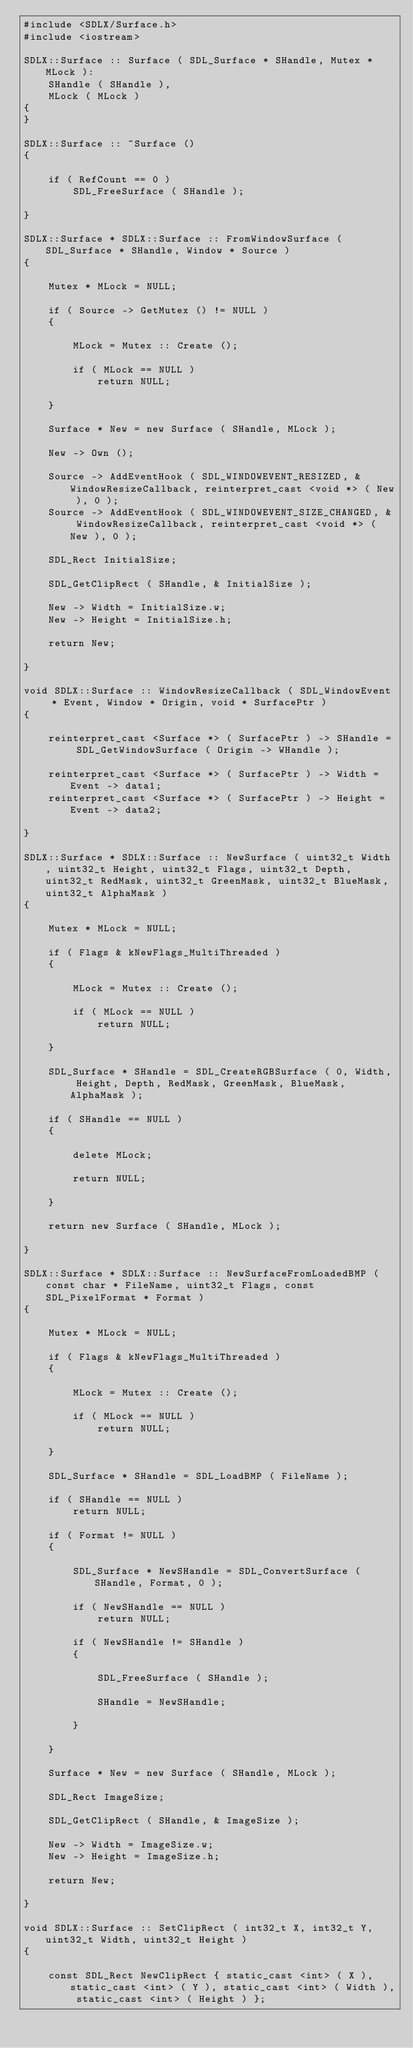Convert code to text. <code><loc_0><loc_0><loc_500><loc_500><_C++_>#include <SDLX/Surface.h>
#include <iostream>

SDLX::Surface :: Surface ( SDL_Surface * SHandle, Mutex * MLock ):
	SHandle ( SHandle ),
	MLock ( MLock )
{
}

SDLX::Surface :: ~Surface ()
{
	
	if ( RefCount == 0 )
		SDL_FreeSurface ( SHandle );
	
}

SDLX::Surface * SDLX::Surface :: FromWindowSurface ( SDL_Surface * SHandle, Window * Source )
{
	
	Mutex * MLock = NULL;
	
	if ( Source -> GetMutex () != NULL )
	{
		
		MLock = Mutex :: Create ();
		
		if ( MLock == NULL )
			return NULL;
		
	}
	
	Surface * New = new Surface ( SHandle, MLock );
	
	New -> Own ();
	
	Source -> AddEventHook ( SDL_WINDOWEVENT_RESIZED, & WindowResizeCallback, reinterpret_cast <void *> ( New ), 0 );
	Source -> AddEventHook ( SDL_WINDOWEVENT_SIZE_CHANGED, & WindowResizeCallback, reinterpret_cast <void *> ( New ), 0 );
	
	SDL_Rect InitialSize;
	
	SDL_GetClipRect ( SHandle, & InitialSize );
	
	New -> Width = InitialSize.w;
	New -> Height = InitialSize.h;
	
	return New;
	
}

void SDLX::Surface :: WindowResizeCallback ( SDL_WindowEvent * Event, Window * Origin, void * SurfacePtr )
{
	
	reinterpret_cast <Surface *> ( SurfacePtr ) -> SHandle = SDL_GetWindowSurface ( Origin -> WHandle );
	
	reinterpret_cast <Surface *> ( SurfacePtr ) -> Width = Event -> data1;
	reinterpret_cast <Surface *> ( SurfacePtr ) -> Height = Event -> data2;
	
}

SDLX::Surface * SDLX::Surface :: NewSurface ( uint32_t Width, uint32_t Height, uint32_t Flags, uint32_t Depth, uint32_t RedMask, uint32_t GreenMask, uint32_t BlueMask, uint32_t AlphaMask )
{
	
	Mutex * MLock = NULL;
	
	if ( Flags & kNewFlags_MultiThreaded )
	{
		
		MLock = Mutex :: Create ();
		
		if ( MLock == NULL )
			return NULL;
		
	}
	
	SDL_Surface * SHandle = SDL_CreateRGBSurface ( 0, Width, Height, Depth, RedMask, GreenMask, BlueMask, AlphaMask );
	
	if ( SHandle == NULL )
	{
		
		delete MLock;
		
		return NULL;
		
	}
	
	return new Surface ( SHandle, MLock );
	
}

SDLX::Surface * SDLX::Surface :: NewSurfaceFromLoadedBMP ( const char * FileName, uint32_t Flags, const SDL_PixelFormat * Format )
{
	
	Mutex * MLock = NULL;
	
	if ( Flags & kNewFlags_MultiThreaded )
	{
		
		MLock = Mutex :: Create ();
		
		if ( MLock == NULL )
			return NULL;
		
	}
	
	SDL_Surface * SHandle = SDL_LoadBMP ( FileName );
	
	if ( SHandle == NULL )
		return NULL;
	
	if ( Format != NULL )
	{
		
		SDL_Surface * NewSHandle = SDL_ConvertSurface ( SHandle, Format, 0 );
		
		if ( NewSHandle == NULL )
			return NULL;
		
		if ( NewSHandle != SHandle )
		{
			
			SDL_FreeSurface ( SHandle );
			
			SHandle = NewSHandle;
			
		}
		
	}
	
	Surface * New = new Surface ( SHandle, MLock );
	
	SDL_Rect ImageSize;
	
	SDL_GetClipRect ( SHandle, & ImageSize );
	
	New -> Width = ImageSize.w;
	New -> Height = ImageSize.h;
	
	return New;
	
}

void SDLX::Surface :: SetClipRect ( int32_t X, int32_t Y, uint32_t Width, uint32_t Height )
{
	
	const SDL_Rect NewClipRect { static_cast <int> ( X ), static_cast <int> ( Y ), static_cast <int> ( Width ), static_cast <int> ( Height ) };
	</code> 